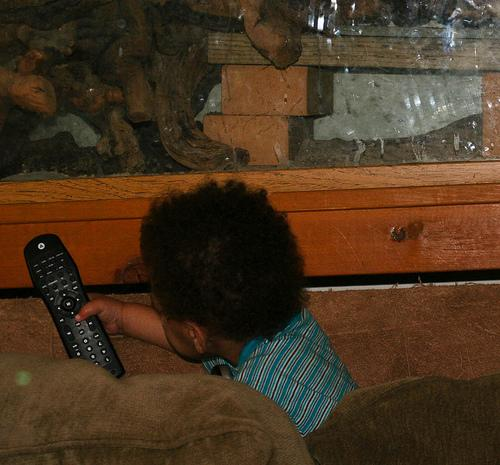What is the glass container likely to be? Please explain your reasoning. fish tank. It has wood and a structure inside it for animals 